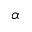<formula> <loc_0><loc_0><loc_500><loc_500>\alpha</formula> 